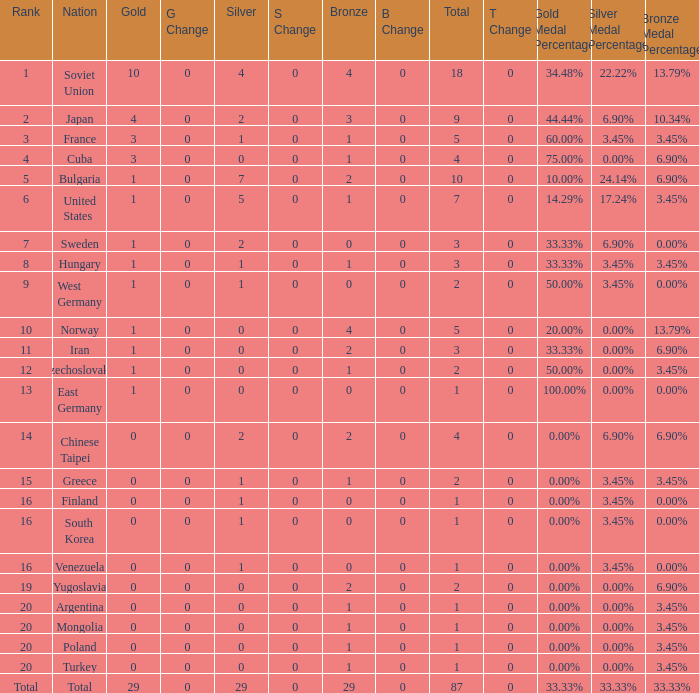What is the average number of bronze medals for total of all nations? 29.0. 